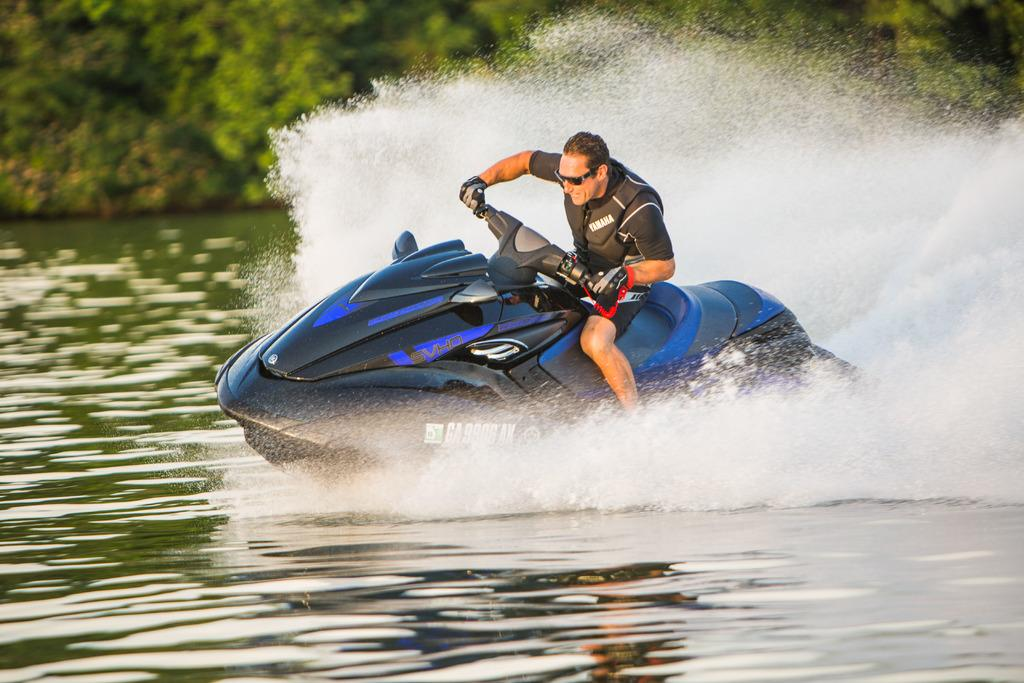What is the person in the image doing? The person is riding a jet ski in the image. Where is the jet ski located? The jet ski is on the water. What can be seen in the background of the image? There are trees visible in the background of the image. How many pigs are attempting to ride the jet ski in the image? There are no pigs present in the image, and therefore no such attempt can be observed. 